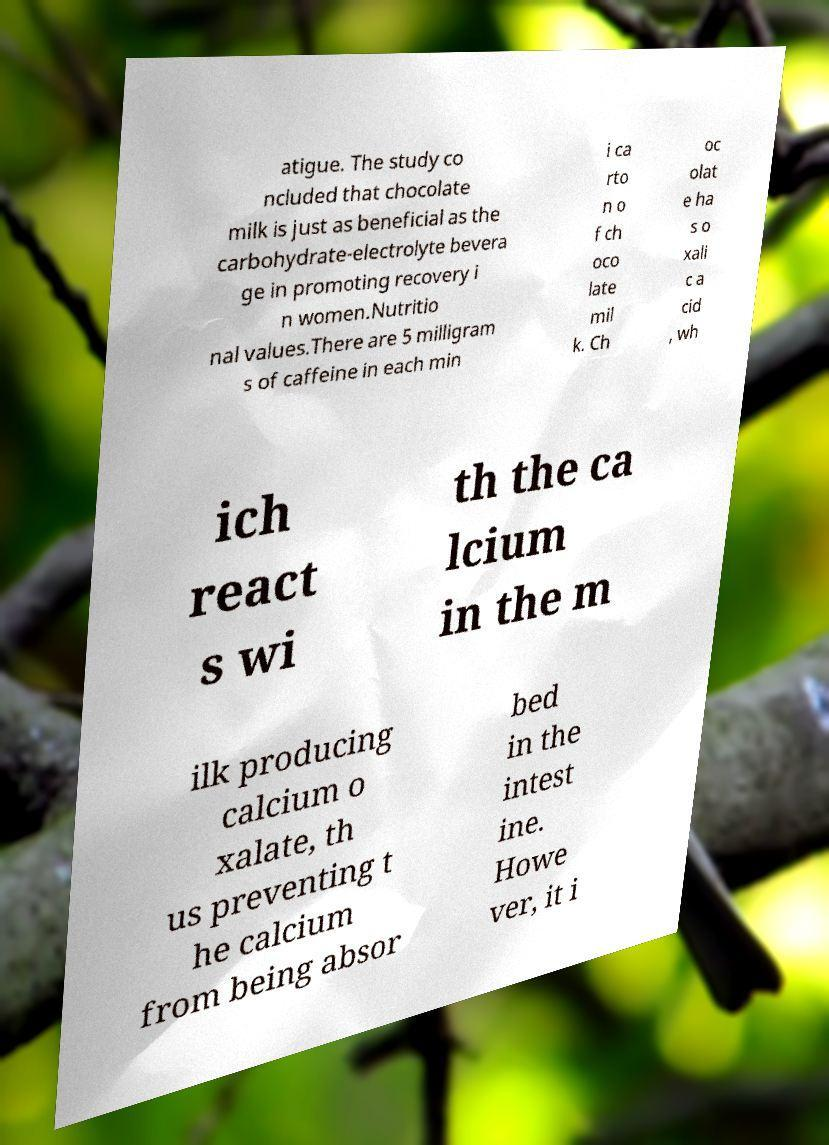There's text embedded in this image that I need extracted. Can you transcribe it verbatim? atigue. The study co ncluded that chocolate milk is just as beneficial as the carbohydrate-electrolyte bevera ge in promoting recovery i n women.Nutritio nal values.There are 5 milligram s of caffeine in each min i ca rto n o f ch oco late mil k. Ch oc olat e ha s o xali c a cid , wh ich react s wi th the ca lcium in the m ilk producing calcium o xalate, th us preventing t he calcium from being absor bed in the intest ine. Howe ver, it i 